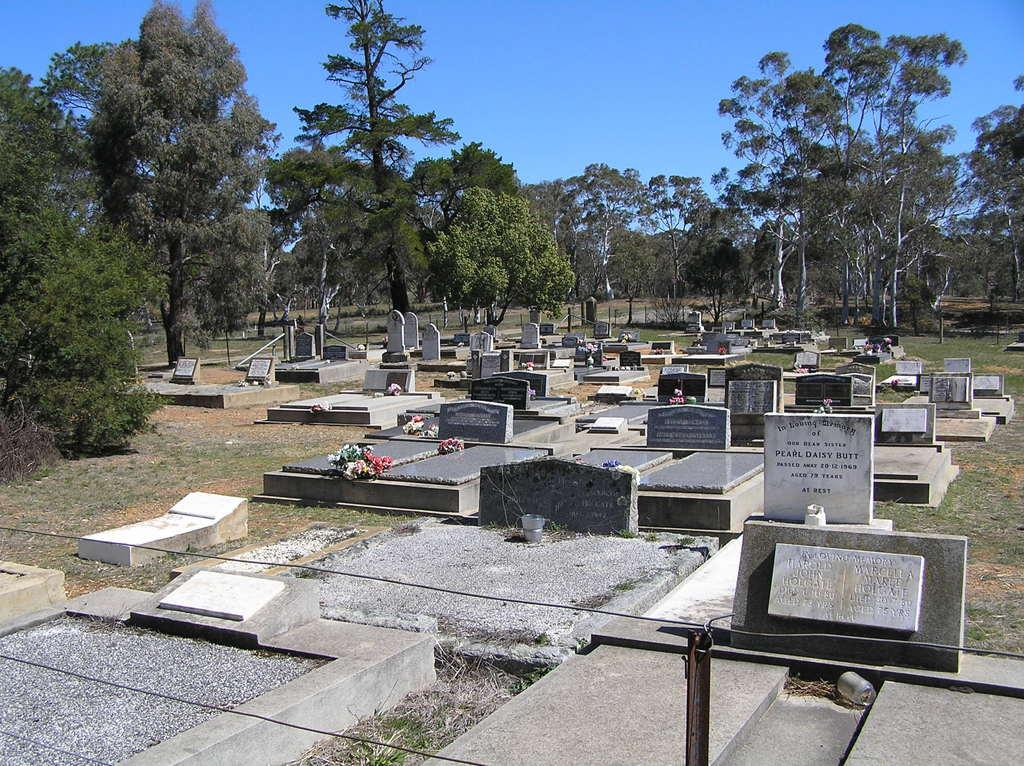What is the main setting of the image? There is a graveyard in the image. What type of vegetation can be seen in the image? There are trees in the image. What is visible in the background of the image? The sky is visible in the background of the image. How many sheep are grazing in the graveyard in the image? There are no sheep present in the image; it features a graveyard with trees and a visible sky. What type of bulb is used to light up the graveyard in the image? There is no mention of any lighting or bulbs in the image; it only shows a graveyard, trees, and the sky. 